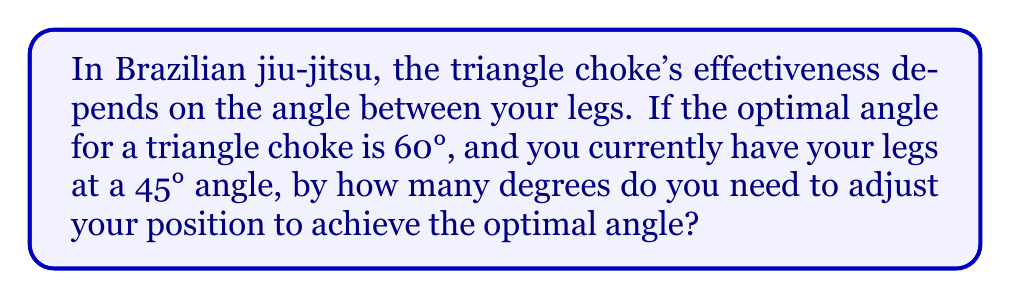Can you answer this question? Let's approach this step-by-step:

1) We are given two angles:
   - Optimal angle: $60°$
   - Current angle: $45°$

2) To find the adjustment needed, we need to calculate the difference between these angles:

   $$\text{Adjustment} = \text{Optimal angle} - \text{Current angle}$$

3) Substituting the values:

   $$\text{Adjustment} = 60° - 45°$$

4) Performing the subtraction:

   $$\text{Adjustment} = 15°$$

Therefore, you need to increase the angle between your legs by 15° to achieve the optimal angle for the triangle choke.

[asy]
import geometry;

size(200);
pair A = (0,0), B = (100,0), C = (50,86.6);
draw(A--B--C--A);
draw(arc(B,30,0,60), blue);
draw(arc(B,30,0,45), red);
label("60°", (85,25), blue);
label("45°", (90,15), red);
label("15°", (80,35));
[/asy]
Answer: $15°$ 